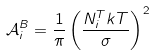<formula> <loc_0><loc_0><loc_500><loc_500>\mathcal { A } _ { i } ^ { B } = \frac { 1 } { \pi } \left ( \frac { N _ { i } ^ { T } k T } { \sigma } \right ) ^ { 2 }</formula> 